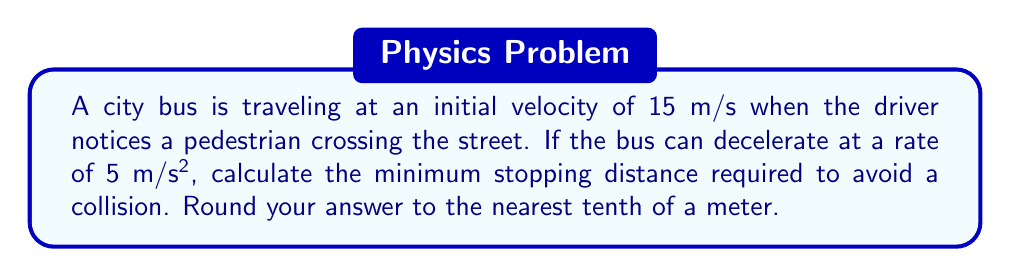Can you answer this question? To solve this problem, we'll use the equation for stopping distance given initial velocity and deceleration rate. The equation is:

$$ d = \frac{v_0^2}{2a} $$

Where:
$d$ = stopping distance
$v_0$ = initial velocity
$a$ = deceleration rate (magnitude)

Given:
$v_0 = 15$ m/s
$a = 5$ m/s²

Let's substitute these values into the equation:

$$ d = \frac{(15 \text{ m/s})^2}{2(5 \text{ m/s}^2)} $$

Simplifying:
$$ d = \frac{225 \text{ m}^2\text{/s}^2}{10 \text{ m/s}^2} $$

$$ d = 22.5 \text{ m} $$

Rounding to the nearest tenth:
$d \approx 22.5$ m
Answer: 22.5 m 